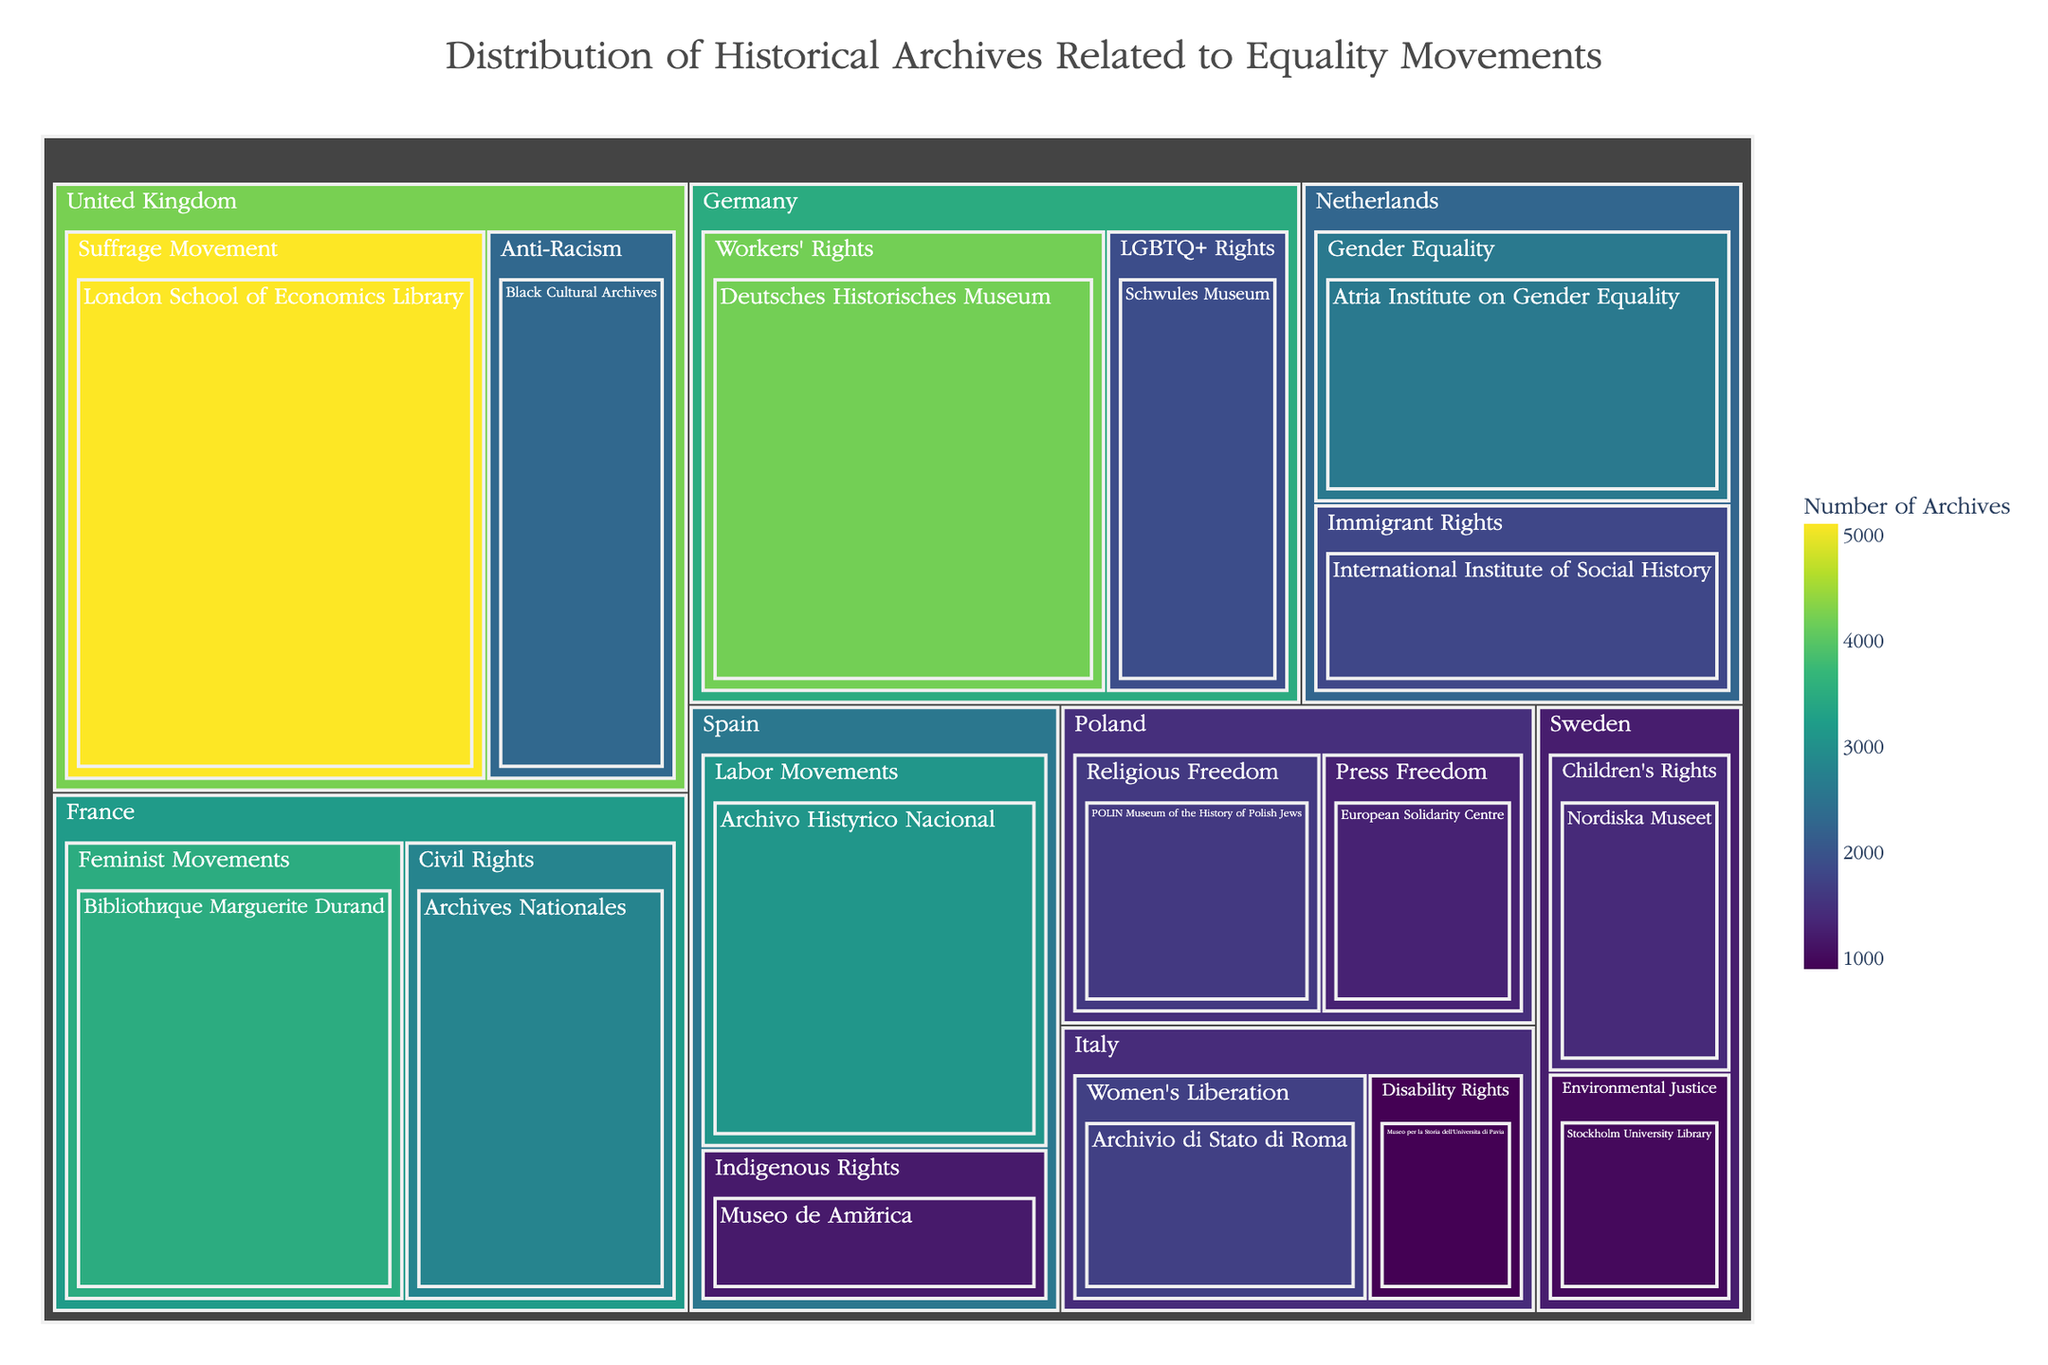What is the title of the figure? The title of the figure is displayed at the top of the treemap, clearly indicating what the visualization represents.
Answer: Distribution of Historical Archives Related to Equality Movements Which country has the institution with the highest number of archives? The institution with the highest number of archives is found by identifying the largest rectangle in the treemap. This institution is located in the United Kingdom.
Answer: United Kingdom How many archives are cataloged for Civil Rights movements in France? Locate the section labeled "France" and identify the subcategory "Civil Rights" to find the number of archives.
Answer: 2800 Which institution in Germany has archives related to Workers' Rights and how many? Within the "Germany" section, locate the subcategory "Workers' Rights" and note the corresponding institution and the number of archives.
Answer: Deutsches Historisches Museum, 4200 Compare the number of archives related to Disability Rights in Italy and Environmental Justice in Sweden. Which one is larger? Locate both the "Disability Rights" subcategory under Italy and the "Environmental Justice" subcategory under Sweden, then compare their sizes in terms of the number of archives.
Answer: Disability Rights in Italy What is the total number of archives related to equality movements in Spain? Sum the number of archives for all subcategories under the "Spain" category: 3100 (Labor Movements) + 1200 (Indigenous Rights).
Answer: 4300 Which subcategory under Netherlands has more archives: Gender Equality or Immigrant Rights? Compare the number of archives between the "Gender Equality" and "Immigrant Rights" subcategories in the Netherlands section.
Answer: Gender Equality What is the average number of archives for subcategories under Poland? Sum the number of archives for all subcategories under the Poland category and divide by the number of subcategories: (1600 + 1300) / 2.
Answer: 1450 Which category in the figure has the most subcategories? Identify which main category (country) in the treemap has the highest number of subcategories.
Answer: France How does the number of archives related to the Suffrage Movement in the United Kingdom compare to those related to Labor Movements in Spain? Compare the numbers shown for the "Suffrage Movement" in the United Kingdom and "Labor Movements" in Spain. The Suffrage Movement has 5100 archives while Labor Movements has 3100.
Answer: Suffrage Movement in the United Kingdom 